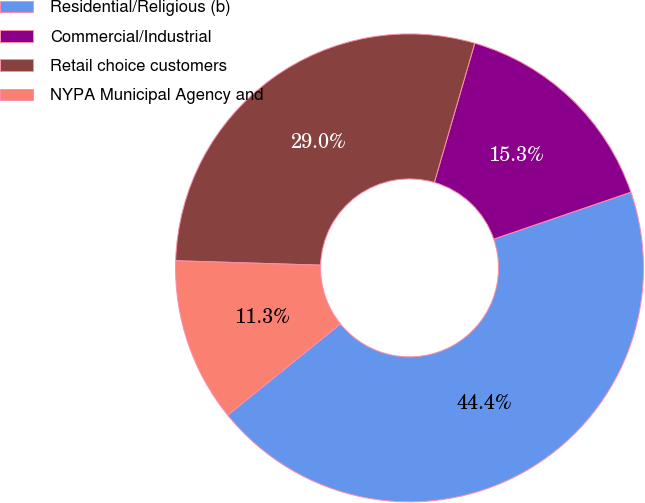Convert chart. <chart><loc_0><loc_0><loc_500><loc_500><pie_chart><fcel>Residential/Religious (b)<fcel>Commercial/Industrial<fcel>Retail choice customers<fcel>NYPA Municipal Agency and<nl><fcel>44.41%<fcel>15.26%<fcel>29.01%<fcel>11.32%<nl></chart> 